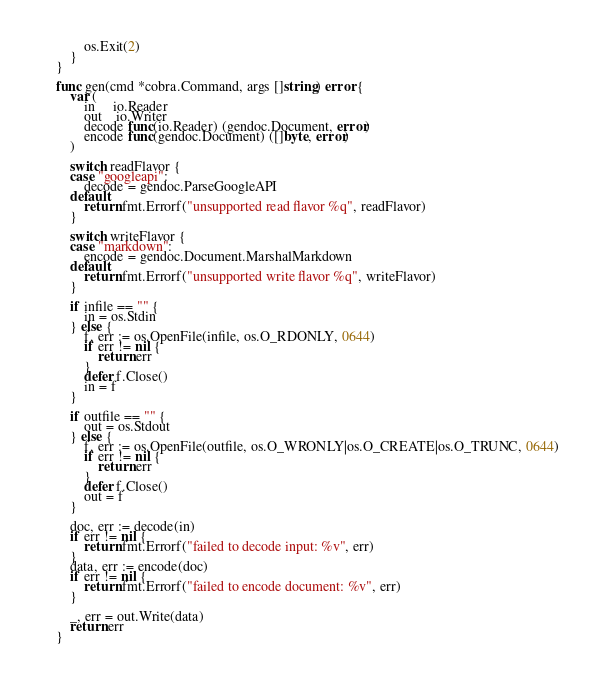<code> <loc_0><loc_0><loc_500><loc_500><_Go_>		os.Exit(2)
	}
}

func gen(cmd *cobra.Command, args []string) error {
	var (
		in     io.Reader
		out    io.Writer
		decode func(io.Reader) (gendoc.Document, error)
		encode func(gendoc.Document) ([]byte, error)
	)

	switch readFlavor {
	case "googleapi":
		decode = gendoc.ParseGoogleAPI
	default:
		return fmt.Errorf("unsupported read flavor %q", readFlavor)
	}

	switch writeFlavor {
	case "markdown":
		encode = gendoc.Document.MarshalMarkdown
	default:
		return fmt.Errorf("unsupported write flavor %q", writeFlavor)
	}

	if infile == "" {
		in = os.Stdin
	} else {
		f, err := os.OpenFile(infile, os.O_RDONLY, 0644)
		if err != nil {
			return err
		}
		defer f.Close()
		in = f
	}

	if outfile == "" {
		out = os.Stdout
	} else {
		f, err := os.OpenFile(outfile, os.O_WRONLY|os.O_CREATE|os.O_TRUNC, 0644)
		if err != nil {
			return err
		}
		defer f.Close()
		out = f
	}

	doc, err := decode(in)
	if err != nil {
		return fmt.Errorf("failed to decode input: %v", err)
	}
	data, err := encode(doc)
	if err != nil {
		return fmt.Errorf("failed to encode document: %v", err)
	}

	_, err = out.Write(data)
	return err
}
</code> 